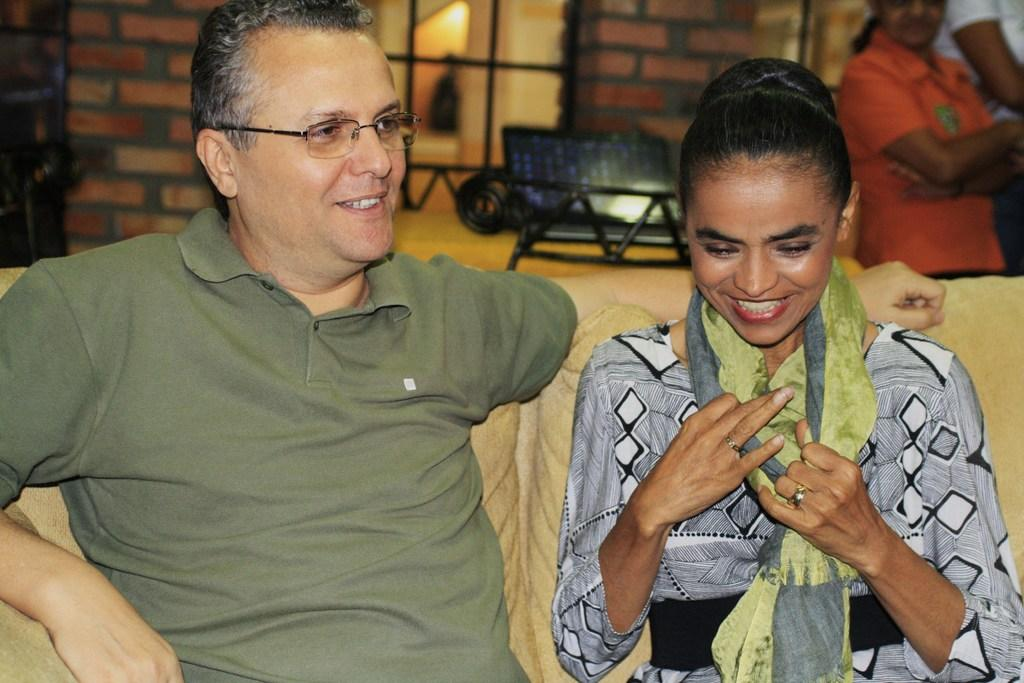What are the people in the image doing? The people on the sofa are sitting and smiling. Can you describe the people in the background of the image? There are people in the background of the image, but their specific actions or expressions are not visible. What can be seen in the background of the image? There is a wall, a bench, and a window in the background of the image. How many cans are visible in the image? There are no cans present in the image. What type of knot is being tied by the people in the image? There is no knot-tying activity depicted in the image. 